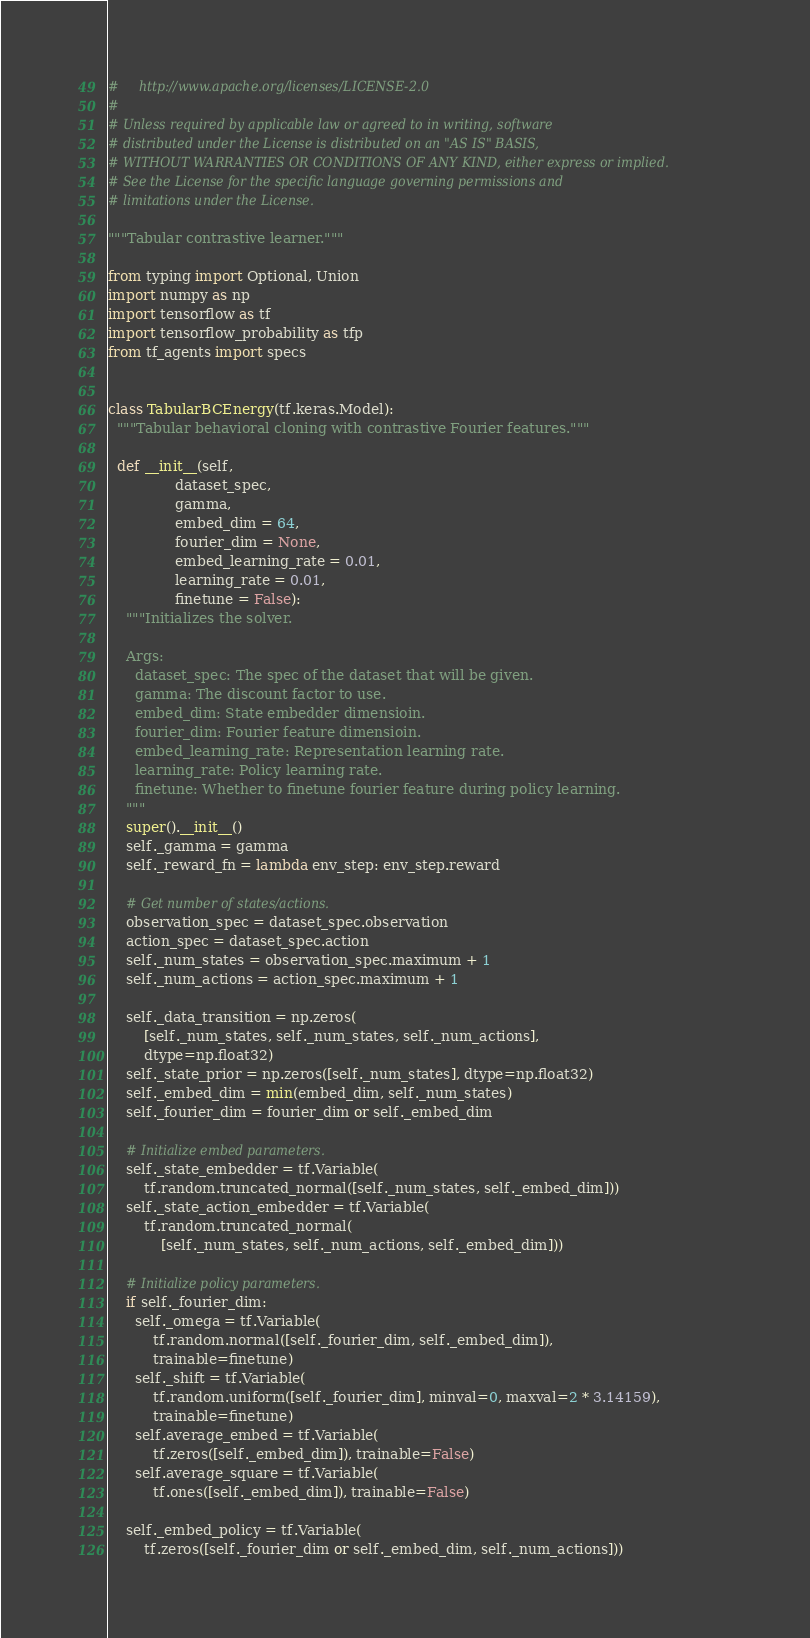<code> <loc_0><loc_0><loc_500><loc_500><_Python_>#     http://www.apache.org/licenses/LICENSE-2.0
#
# Unless required by applicable law or agreed to in writing, software
# distributed under the License is distributed on an "AS IS" BASIS,
# WITHOUT WARRANTIES OR CONDITIONS OF ANY KIND, either express or implied.
# See the License for the specific language governing permissions and
# limitations under the License.

"""Tabular contrastive learner."""

from typing import Optional, Union
import numpy as np
import tensorflow as tf
import tensorflow_probability as tfp
from tf_agents import specs


class TabularBCEnergy(tf.keras.Model):
  """Tabular behavioral cloning with contrastive Fourier features."""

  def __init__(self,
               dataset_spec,
               gamma,
               embed_dim = 64,
               fourier_dim = None,
               embed_learning_rate = 0.01,
               learning_rate = 0.01,
               finetune = False):
    """Initializes the solver.

    Args:
      dataset_spec: The spec of the dataset that will be given.
      gamma: The discount factor to use.
      embed_dim: State embedder dimensioin.
      fourier_dim: Fourier feature dimensioin.
      embed_learning_rate: Representation learning rate.
      learning_rate: Policy learning rate.
      finetune: Whether to finetune fourier feature during policy learning.
    """
    super().__init__()
    self._gamma = gamma
    self._reward_fn = lambda env_step: env_step.reward

    # Get number of states/actions.
    observation_spec = dataset_spec.observation
    action_spec = dataset_spec.action
    self._num_states = observation_spec.maximum + 1
    self._num_actions = action_spec.maximum + 1

    self._data_transition = np.zeros(
        [self._num_states, self._num_states, self._num_actions],
        dtype=np.float32)
    self._state_prior = np.zeros([self._num_states], dtype=np.float32)
    self._embed_dim = min(embed_dim, self._num_states)
    self._fourier_dim = fourier_dim or self._embed_dim

    # Initialize embed parameters.
    self._state_embedder = tf.Variable(
        tf.random.truncated_normal([self._num_states, self._embed_dim]))
    self._state_action_embedder = tf.Variable(
        tf.random.truncated_normal(
            [self._num_states, self._num_actions, self._embed_dim]))

    # Initialize policy parameters.
    if self._fourier_dim:
      self._omega = tf.Variable(
          tf.random.normal([self._fourier_dim, self._embed_dim]),
          trainable=finetune)
      self._shift = tf.Variable(
          tf.random.uniform([self._fourier_dim], minval=0, maxval=2 * 3.14159),
          trainable=finetune)
      self.average_embed = tf.Variable(
          tf.zeros([self._embed_dim]), trainable=False)
      self.average_square = tf.Variable(
          tf.ones([self._embed_dim]), trainable=False)

    self._embed_policy = tf.Variable(
        tf.zeros([self._fourier_dim or self._embed_dim, self._num_actions]))
</code> 